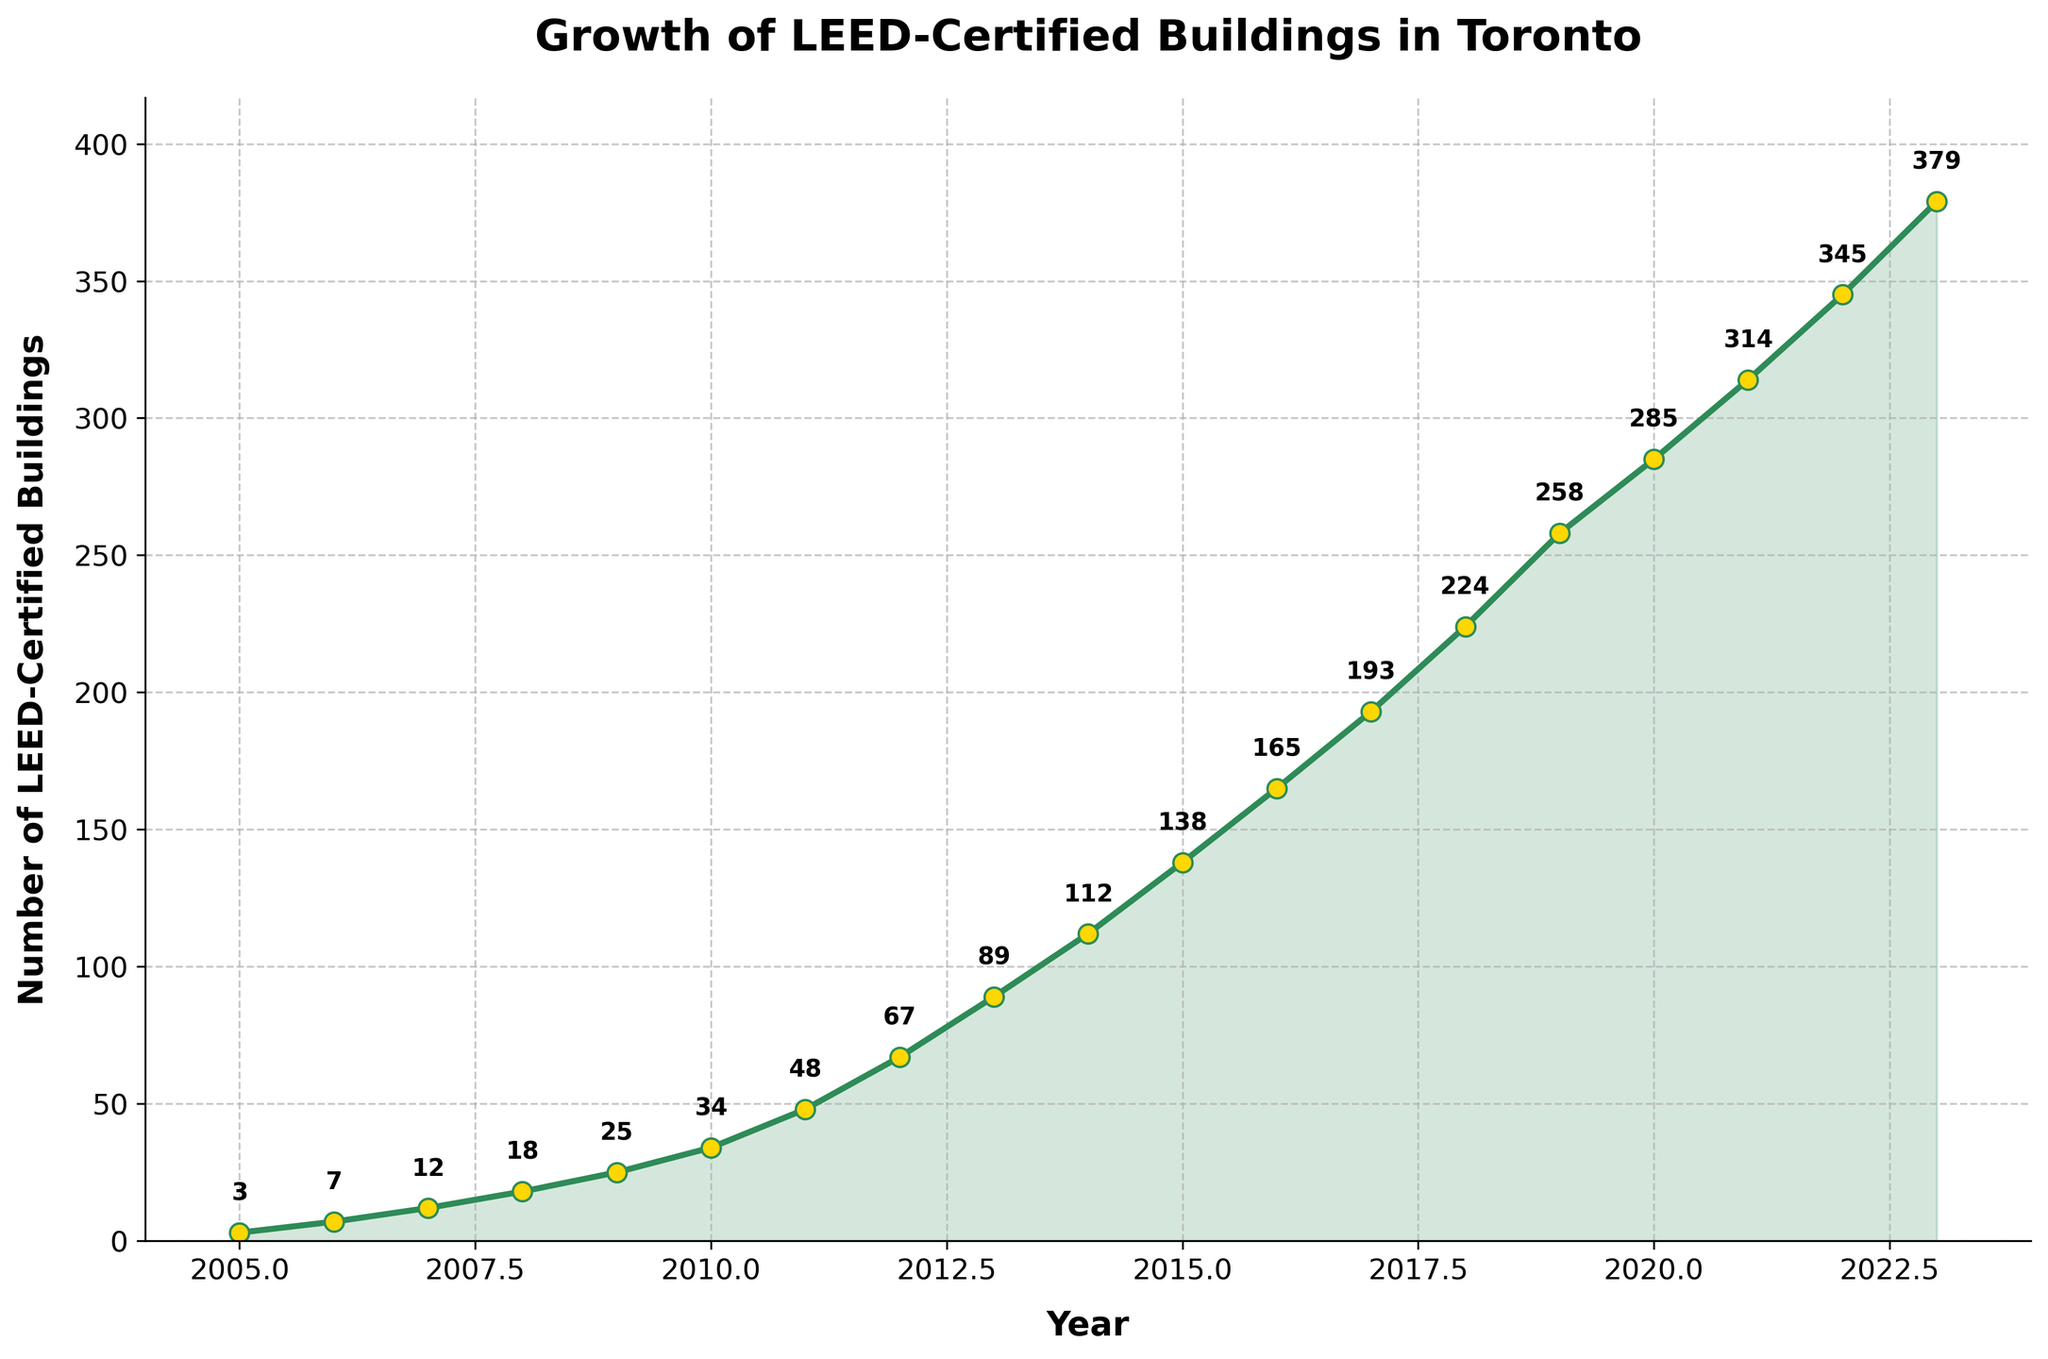What's the total number of LEED-certified buildings in Toronto by the year 2010? To find the total number of buildings by 2010, look for the value in the year 2010. The chart shows 34 buildings in 2010.
Answer: 34 In which year was the growth in the number of LEED-certified buildings the highest? To determine this, we need to compare the increase in buildings for each consecutive year. The largest yearly increase is from 2011 (48 buildings) to 2012 (67 buildings), which is 19.
Answer: 2012 Which year had a higher number of LEED-certified buildings, 2015 or 2020? Compare the values for 2015 and 2020. The chart shows 138 buildings in 2015 and 285 buildings in 2020.
Answer: 2020 How many LEED-certified buildings were there in 2007 and 2017 combined? Add the number of buildings in 2007 (12) and 2017 (193). 12 + 193 = 205
Answer: 205 What is the average annual increase in the number of LEED-certified buildings from 2005 to 2010? First, find the total increase from 2005 (3 buildings) to 2010 (34 buildings), which is 34 - 3 = 31. Then, divide by the number of years: 31 / 5 = 6.2
Answer: 6.2 Is the trend in LEED-certified buildings' growth linear or exponential? Observe the general shape and growth rate shown in the chart. The chart shows a rapid increase year over year, suggesting exponential growth.
Answer: Exponential What was the total increase in the number of LEED-certified buildings from 2018 to 2023? Subtract the number of buildings in 2018 (224) from the number in 2023 (379). 379 - 224 = 155
Answer: 155 What color is the line representing the number of LEED-certified buildings? The line representing the data is visually green in color.
Answer: Green What percentage of the total number of LEED-certified buildings by 2023 were certified by 2015? Divide the number of buildings in 2015 (138) by the total in 2023 (379) and multiply by 100. (138 / 379) * 100 ≈ 36.41%
Answer: ≈ 36.41% Which year marked the first instance of more than 100 LEED-certified buildings? On examining the values, the year 2014 has more than 100 buildings, with 112 certified buildings.
Answer: 2014 